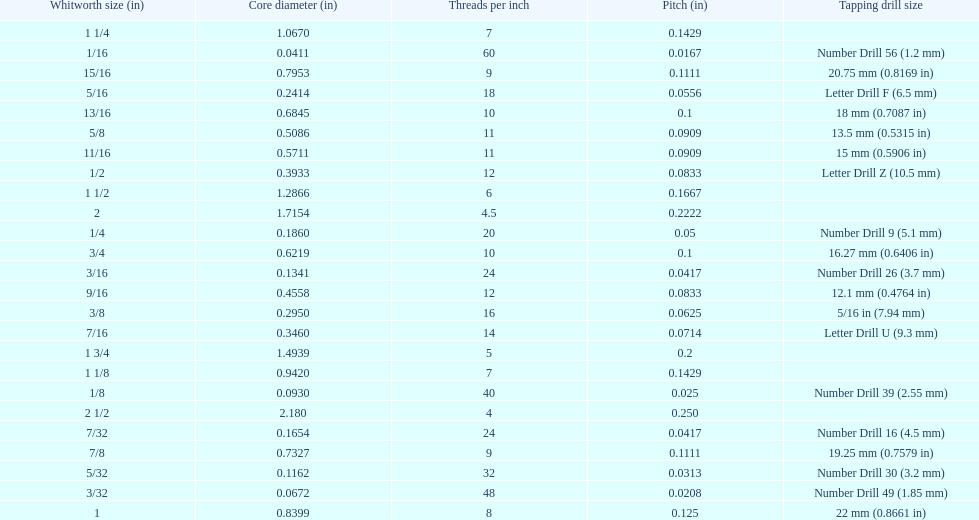What core diameter (in) comes after 0.0930? 0.1162. 